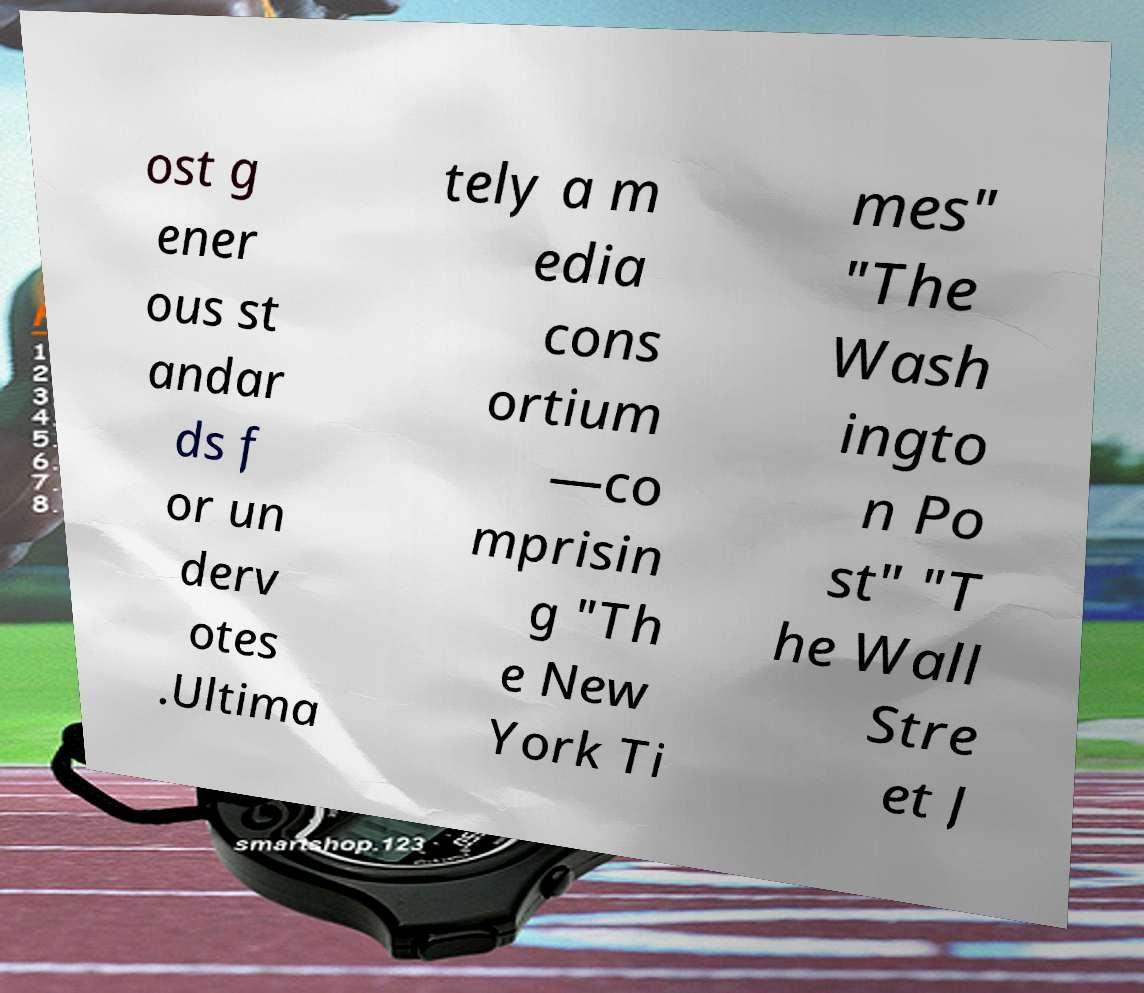What messages or text are displayed in this image? I need them in a readable, typed format. ost g ener ous st andar ds f or un derv otes .Ultima tely a m edia cons ortium —co mprisin g "Th e New York Ti mes" "The Wash ingto n Po st" "T he Wall Stre et J 